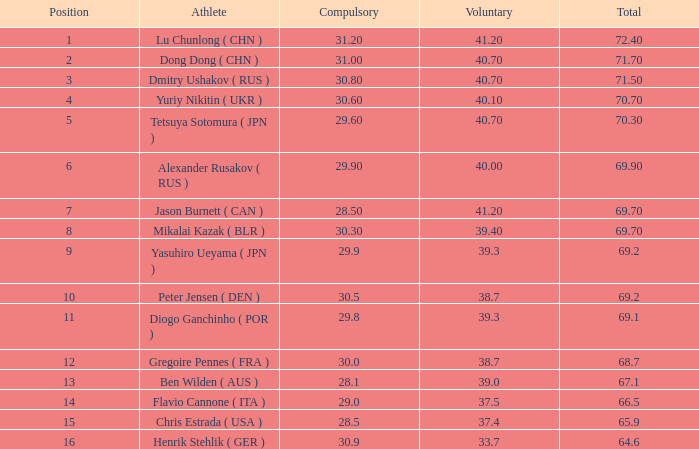7? 0.0. 